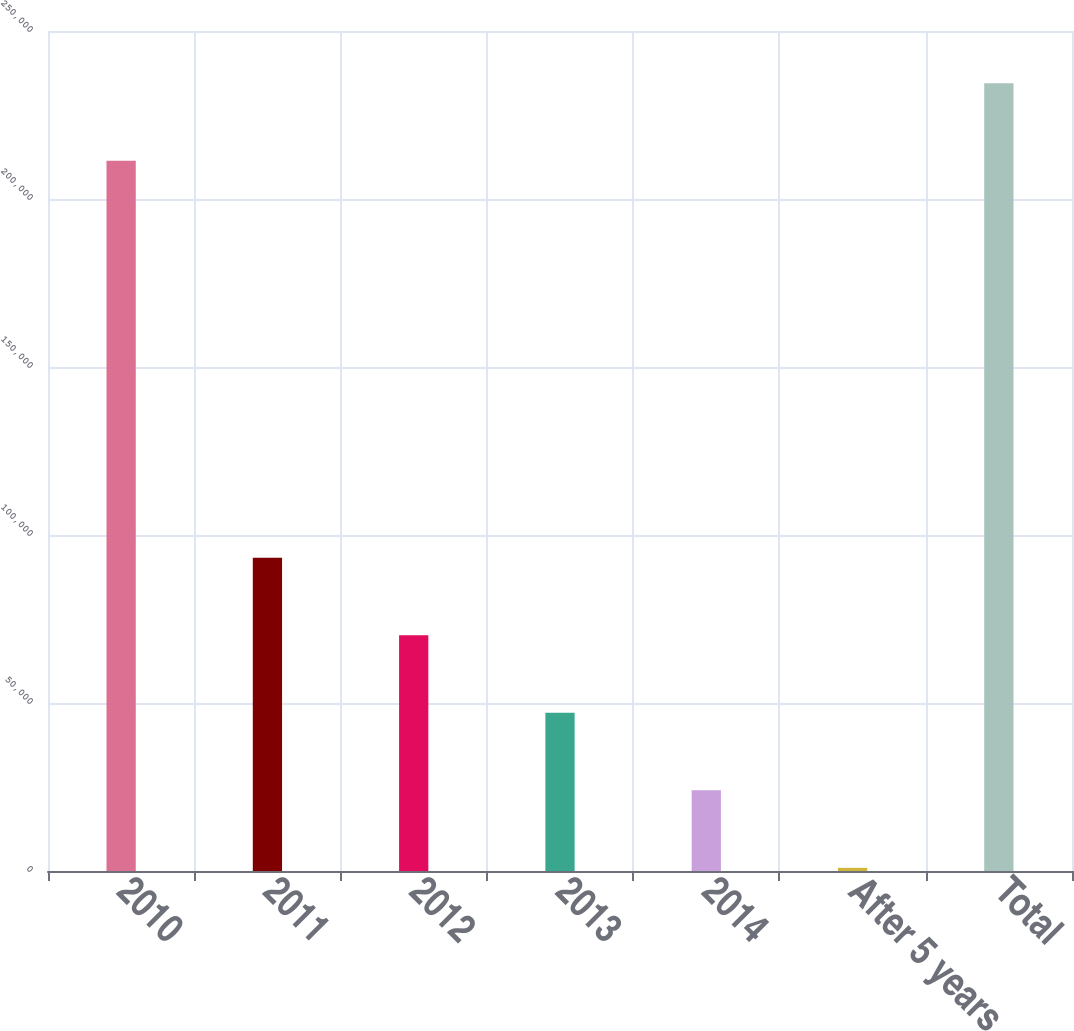Convert chart. <chart><loc_0><loc_0><loc_500><loc_500><bar_chart><fcel>2010<fcel>2011<fcel>2012<fcel>2013<fcel>2014<fcel>After 5 years<fcel>Total<nl><fcel>211377<fcel>93226.4<fcel>70154.3<fcel>47082.2<fcel>24010.1<fcel>938<fcel>234449<nl></chart> 